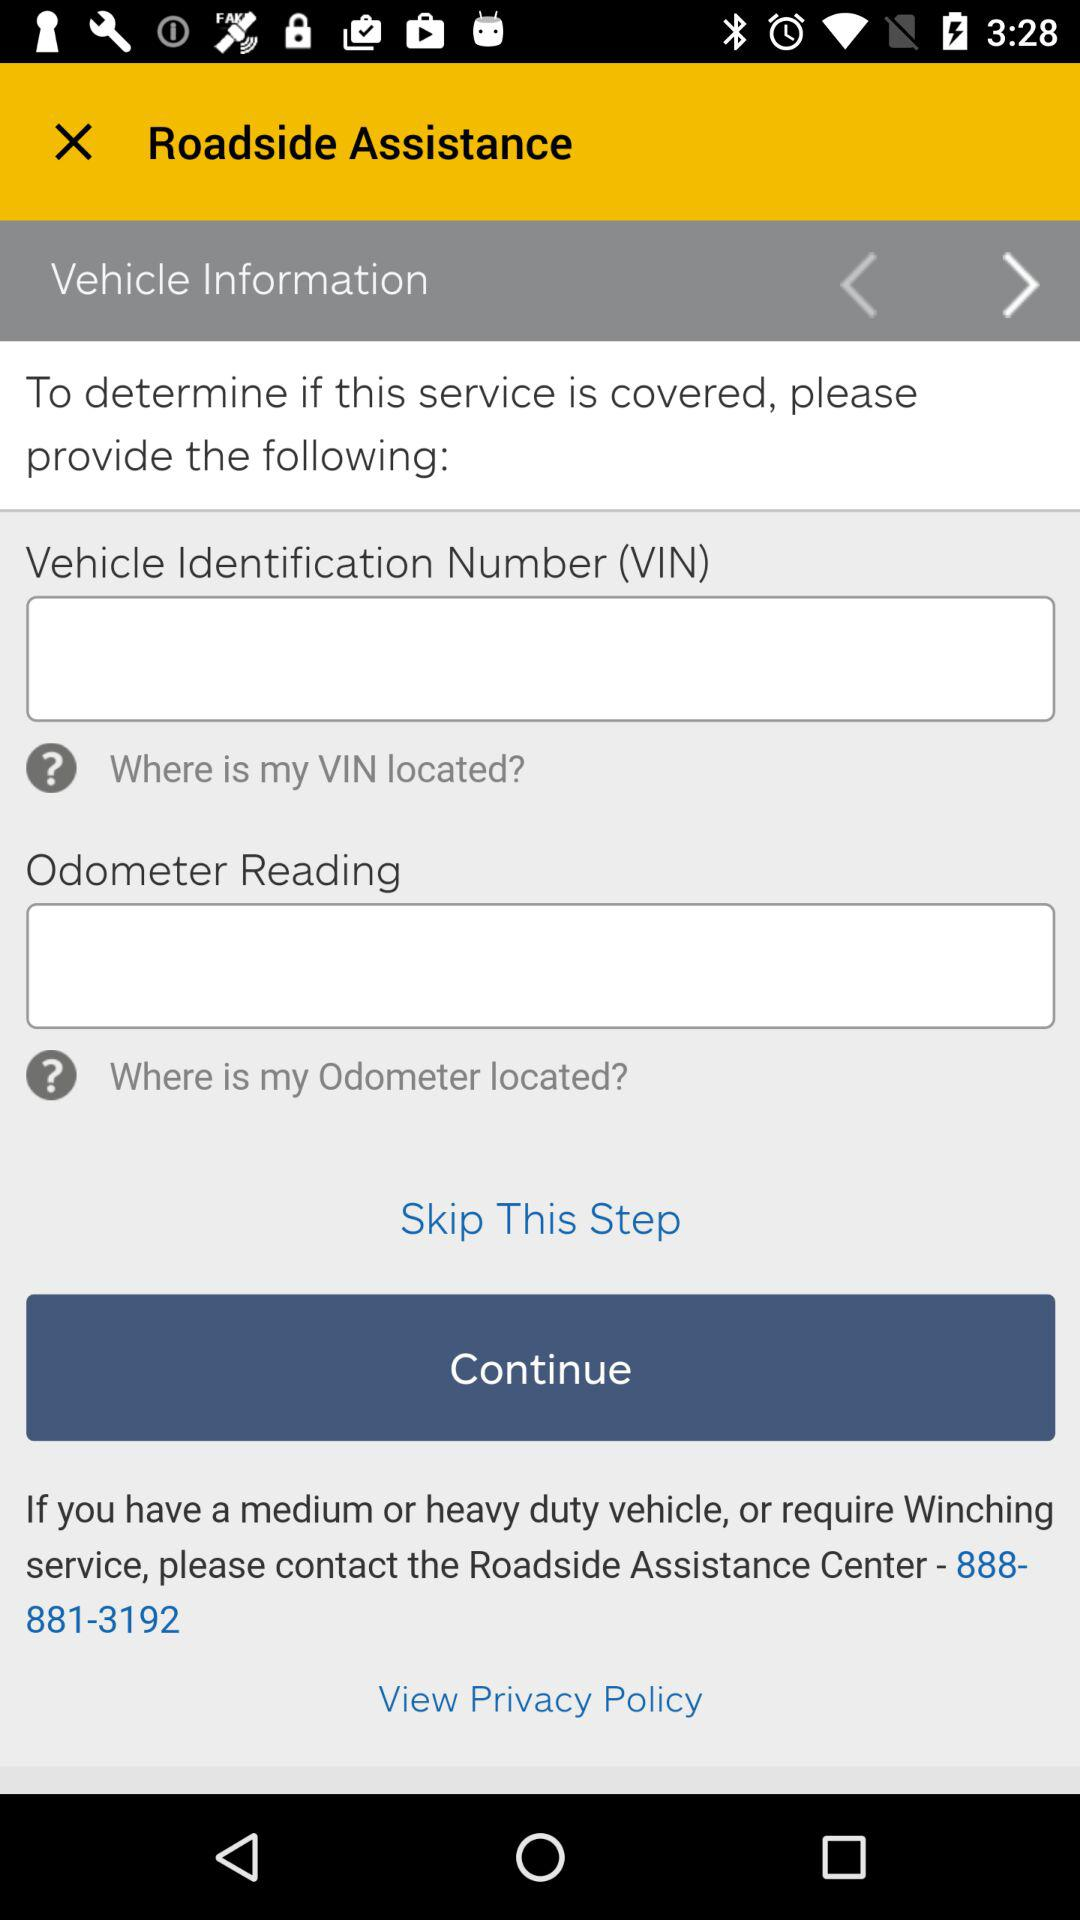What is the contact number of the Roadside Assistance Center? The contact number is 888-881-3192. 